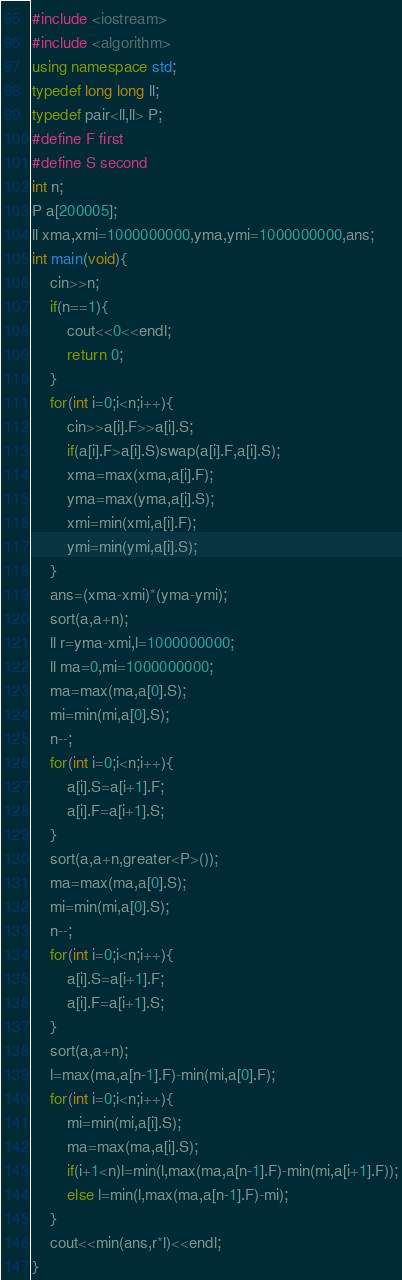<code> <loc_0><loc_0><loc_500><loc_500><_C++_>#include <iostream>
#include <algorithm>
using namespace std;
typedef long long ll;
typedef pair<ll,ll> P;
#define F first
#define S second
int n;
P a[200005];
ll xma,xmi=1000000000,yma,ymi=1000000000,ans;
int main(void){
    cin>>n;
    if(n==1){
        cout<<0<<endl;
        return 0;
    }
    for(int i=0;i<n;i++){
        cin>>a[i].F>>a[i].S;
        if(a[i].F>a[i].S)swap(a[i].F,a[i].S);
        xma=max(xma,a[i].F);
        yma=max(yma,a[i].S);
        xmi=min(xmi,a[i].F);
        ymi=min(ymi,a[i].S);
    }
    ans=(xma-xmi)*(yma-ymi);
    sort(a,a+n);
    ll r=yma-xmi,l=1000000000;
    ll ma=0,mi=1000000000;
    ma=max(ma,a[0].S);
    mi=min(mi,a[0].S);
    n--;
    for(int i=0;i<n;i++){
        a[i].S=a[i+1].F;
        a[i].F=a[i+1].S;
    }
    sort(a,a+n,greater<P>());
    ma=max(ma,a[0].S);
    mi=min(mi,a[0].S);
    n--;
    for(int i=0;i<n;i++){
        a[i].S=a[i+1].F;
        a[i].F=a[i+1].S;
    }
    sort(a,a+n);
    l=max(ma,a[n-1].F)-min(mi,a[0].F);
    for(int i=0;i<n;i++){
        mi=min(mi,a[i].S);
        ma=max(ma,a[i].S);
        if(i+1<n)l=min(l,max(ma,a[n-1].F)-min(mi,a[i+1].F));
        else l=min(l,max(ma,a[n-1].F)-mi);
    }
    cout<<min(ans,r*l)<<endl;
}</code> 